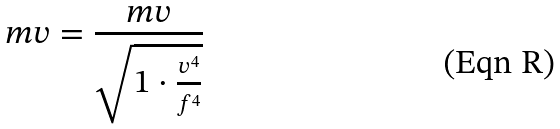Convert formula to latex. <formula><loc_0><loc_0><loc_500><loc_500>m v = \frac { m v } { \sqrt { 1 \cdot \frac { v ^ { 4 } } { f ^ { 4 } } } }</formula> 